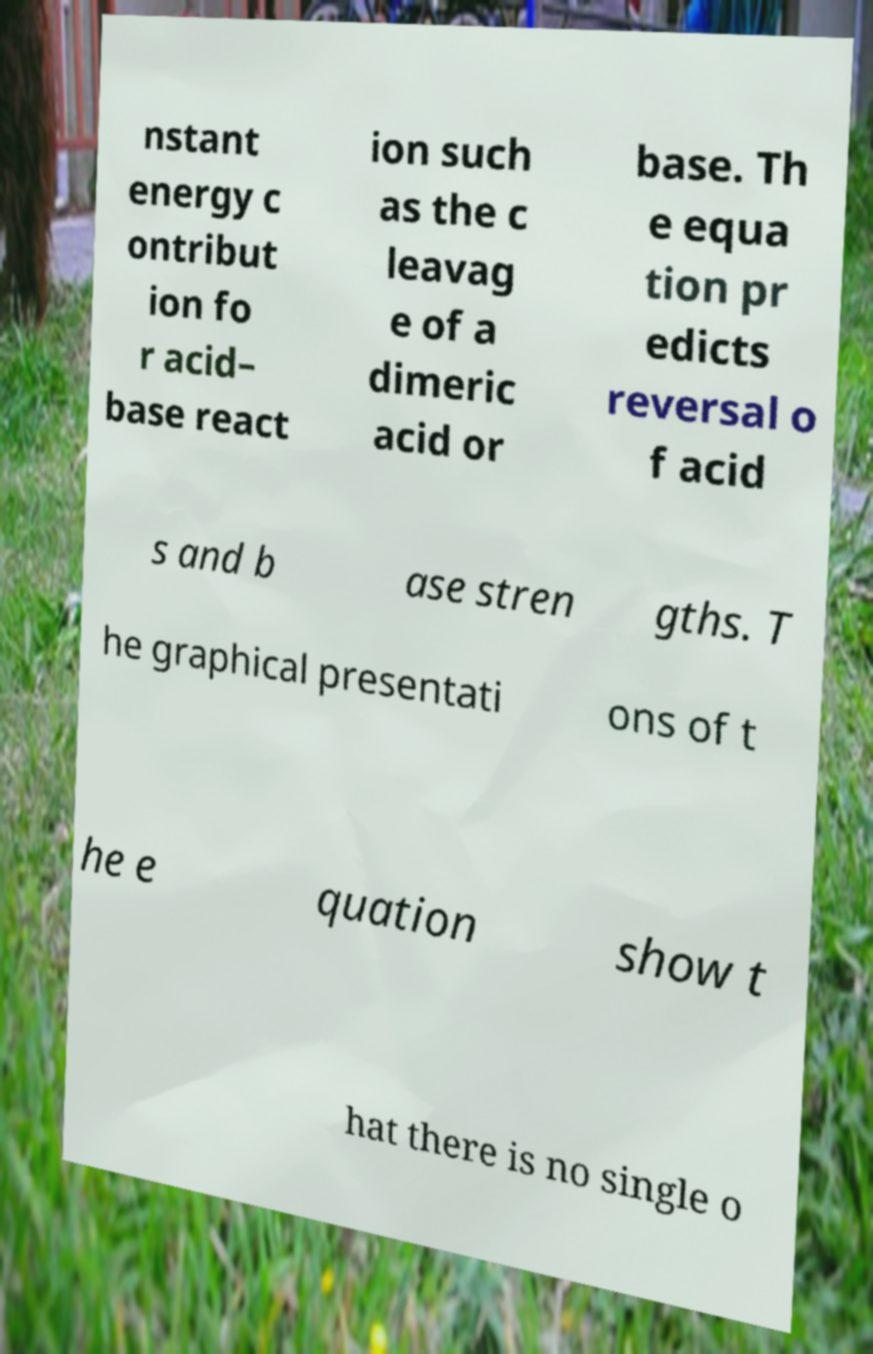Can you read and provide the text displayed in the image?This photo seems to have some interesting text. Can you extract and type it out for me? nstant energy c ontribut ion fo r acid– base react ion such as the c leavag e of a dimeric acid or base. Th e equa tion pr edicts reversal o f acid s and b ase stren gths. T he graphical presentati ons of t he e quation show t hat there is no single o 